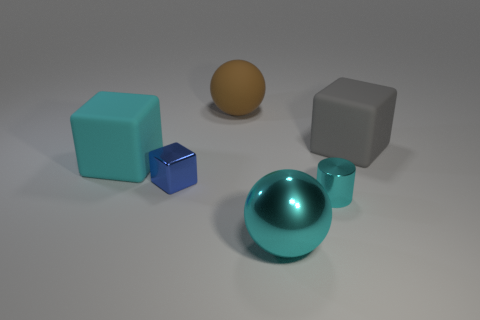Add 2 brown matte things. How many objects exist? 8 Subtract all balls. How many objects are left? 4 Subtract all purple matte balls. Subtract all cyan rubber things. How many objects are left? 5 Add 5 small metal cubes. How many small metal cubes are left? 6 Add 3 big blocks. How many big blocks exist? 5 Subtract 1 gray cubes. How many objects are left? 5 